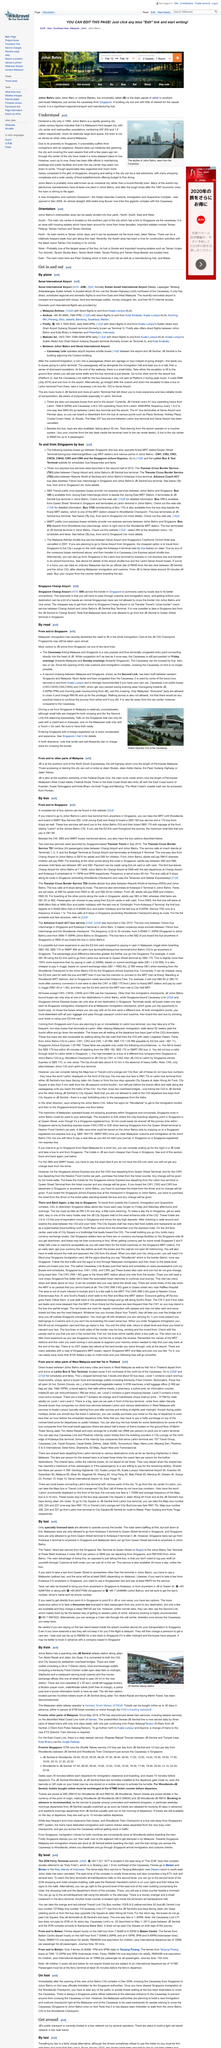Draw attention to some important aspects in this diagram. The title of the top heading is "Understanding the Importance of Regular Dental Check-Ups. Johor Bahru was officially declared a city in the year 1994. The skyline of Johor Bahru is depicted in this image. 